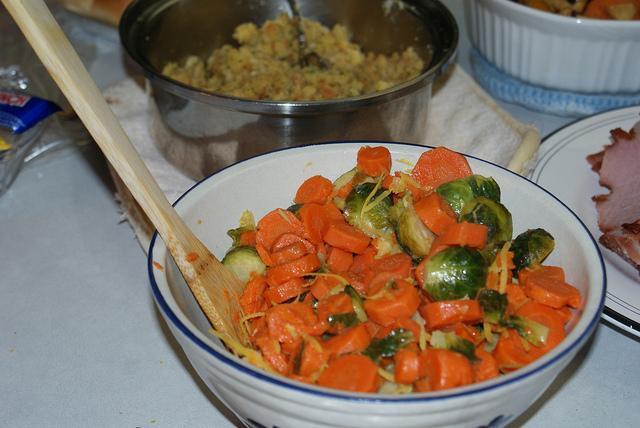How many vegetables are in the bowl?
Give a very brief answer. 2. How many dining tables are there?
Give a very brief answer. 1. How many carrots can be seen?
Give a very brief answer. 4. How many bowls are in the picture?
Give a very brief answer. 3. 